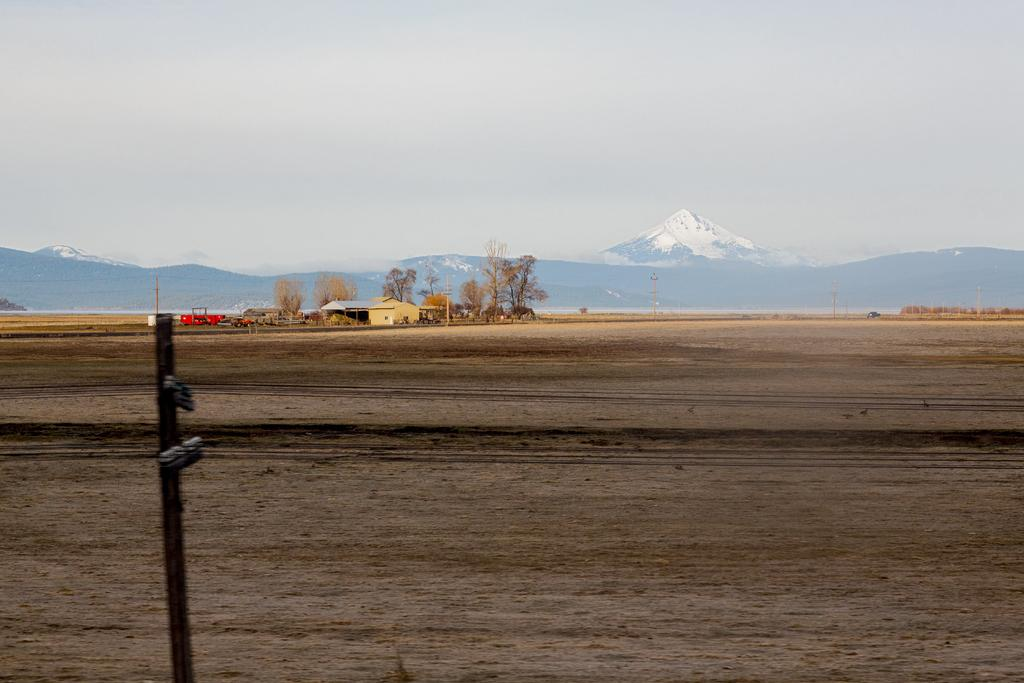What type of structures can be seen in the image? There are houses in the image. What natural elements are present in the image? There are trees and mountains in the image. What man-made objects can be seen in the image? There are poles in the image. What color is the object that stands out in the image? There is a red color object in the image. What is the color of the sky in the image? The sky is blue and white in color. Where is the playground located in the image? There is no playground present in the image. What type of observation can be made about the current weather in the image? The image does not provide any information about the current weather, as it only shows the sky's color. 